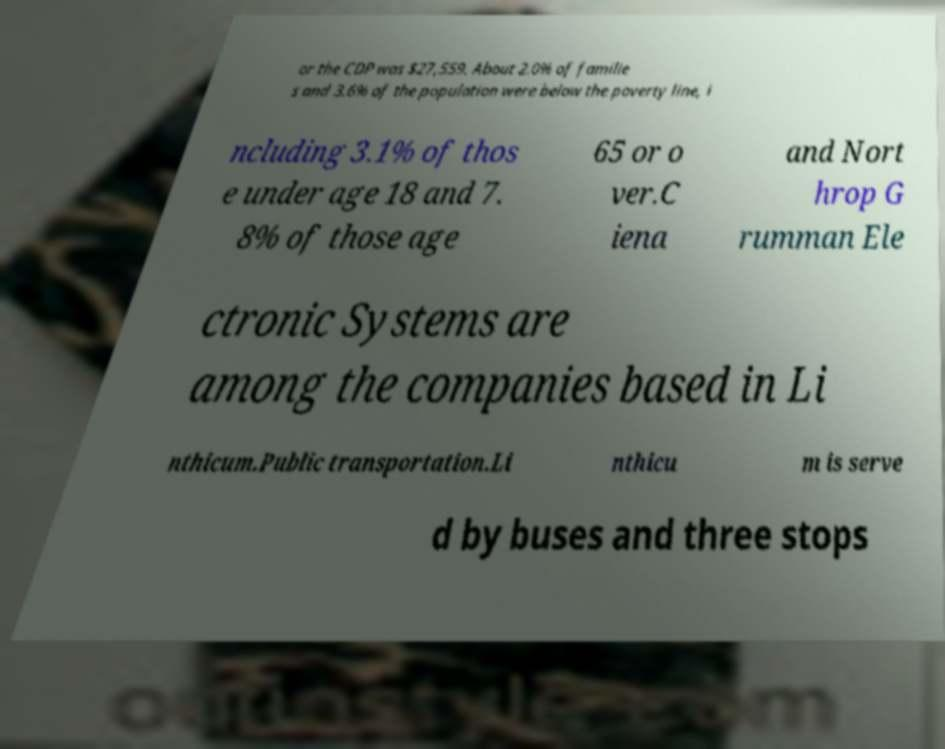Can you read and provide the text displayed in the image?This photo seems to have some interesting text. Can you extract and type it out for me? or the CDP was $27,559. About 2.0% of familie s and 3.6% of the population were below the poverty line, i ncluding 3.1% of thos e under age 18 and 7. 8% of those age 65 or o ver.C iena and Nort hrop G rumman Ele ctronic Systems are among the companies based in Li nthicum.Public transportation.Li nthicu m is serve d by buses and three stops 